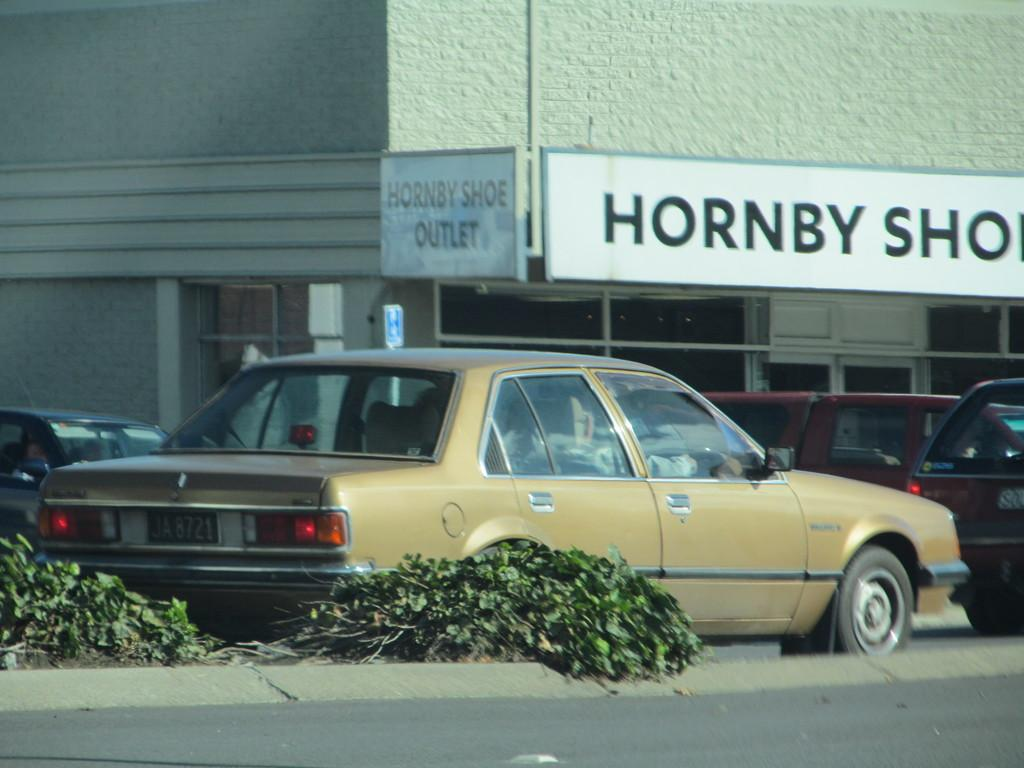What types of objects are present in the image? There are vehicles and plants on the ground in the image. What can be seen in the background of the image? There is a building and boards in the background of the image. Can you see the ocean in the image? No, there is no ocean visible in the image. 